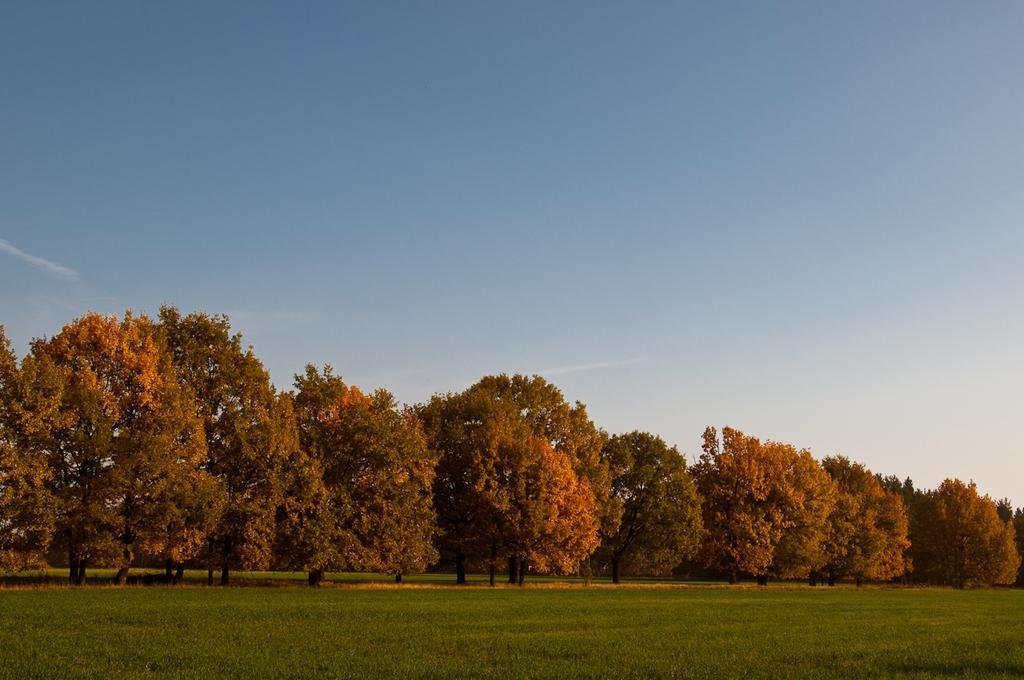What type of vegetation is present on the ground in the image? There is grass on the ground in the image. What can be seen in the distance in the image? There are trees in the background of the image. What day of the week is it at the seashore in the image? There is no seashore present in the image, and therefore no indication of the day of the week. 